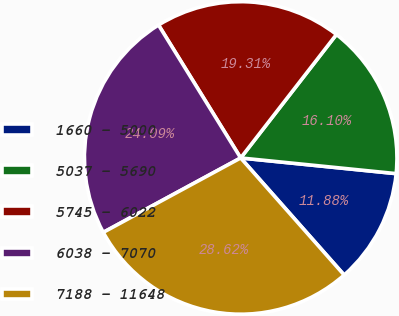Convert chart to OTSL. <chart><loc_0><loc_0><loc_500><loc_500><pie_chart><fcel>1660 - 5000<fcel>5037 - 5690<fcel>5745 - 6022<fcel>6038 - 7070<fcel>7188 - 11648<nl><fcel>11.88%<fcel>16.1%<fcel>19.31%<fcel>24.09%<fcel>28.62%<nl></chart> 